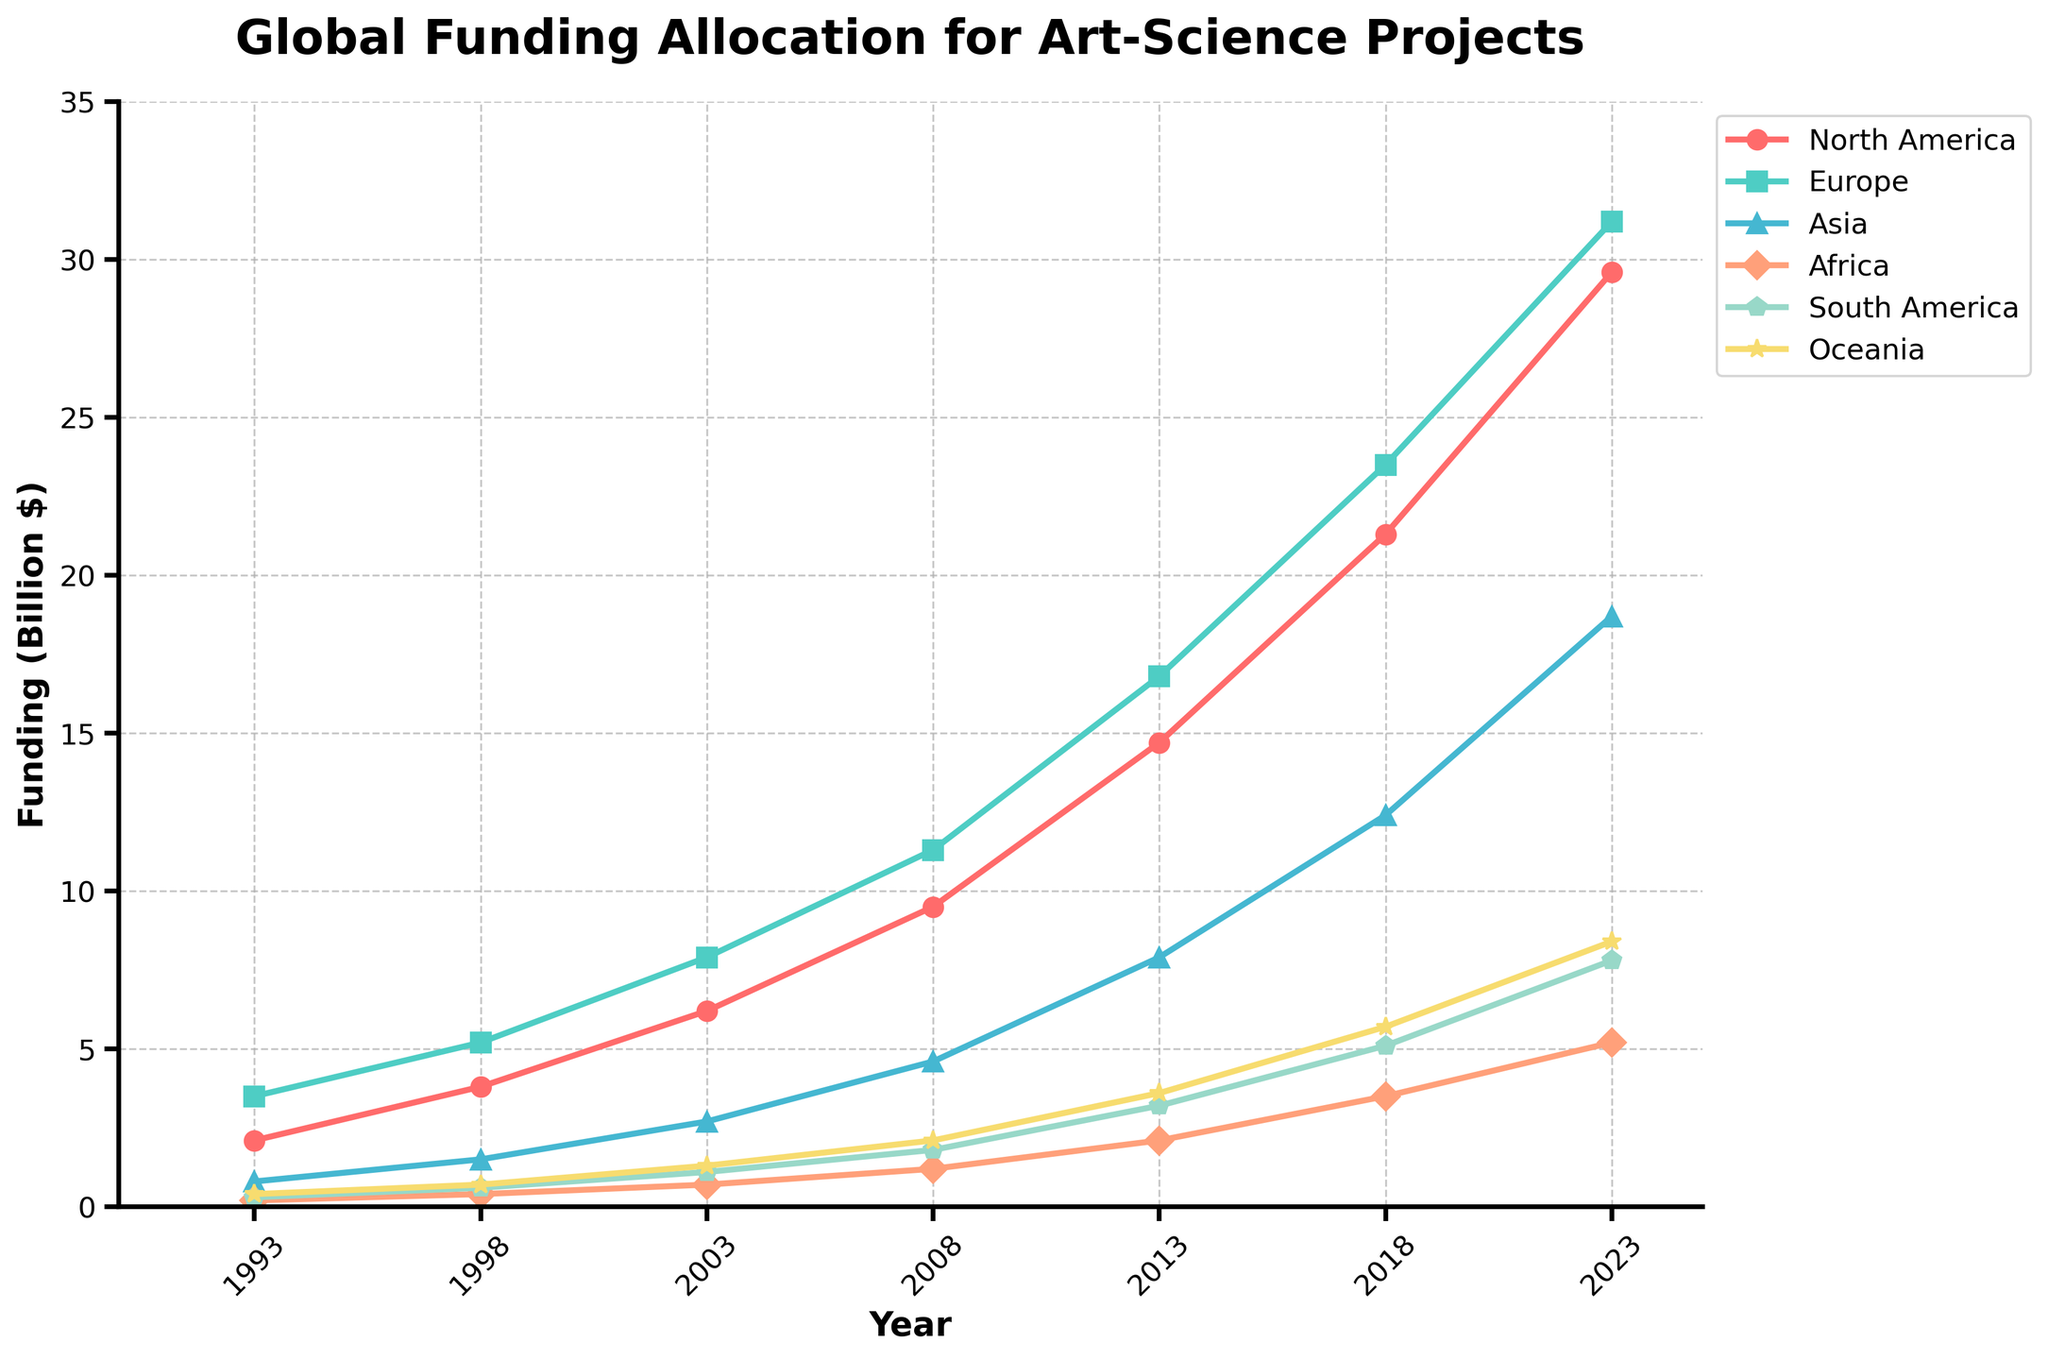Which continent had the highest funding allocation in 2023? To determine the highest funding in 2023, compare the funding values for each continent. North America has 29.6, Europe has 31.2, Asia has 18.7, Africa has 5.2, South America has 7.8, and Oceania has 8.4. Europe has the highest value.
Answer: Europe What is the overall trend of funding in North America over the 30 years? To determine the trend, observe the funding values for North America from 1993 to 2023: 2.1, 3.8, 6.2, 9.5, 14.7, 21.3, 29.6. There is a consistent increase in funding over the years.
Answer: Increasing Which continents had funding allocations below 5 billion dollars in 2008? Look at the funding values for each continent in 2008: North America 9.5, Europe 11.3, Asia 4.6, Africa 1.2, South America 1.8, and Oceania 2.1. The continents with funding below 5 billion dollars are Asia, Africa, South America, and Oceania.
Answer: Asia, Africa, South America, Oceania By how much did funding in Europe increase from 1993 to 2023? Subtract Europe's funding in 1993 from its funding in 2023. The funding in 1993 is 3.5 and in 2023 is 31.2. The increase is 31.2 - 3.5 = 27.7 billion dollars.
Answer: 27.7 billion dollars Which continent had the smallest funding increase over the 30 years? Calculate the difference between the 1993 and 2023 values for each continent: North America (29.6 - 2.1 = 27.5), Europe (31.2 - 3.5 = 27.7), Asia (18.7 - 0.8 = 17.9), Africa (5.2 - 0.2 = 5.0), South America (7.8 - 0.3 = 7.5), Oceania (8.4 - 0.4 = 8.0). Africa has the smallest increase.
Answer: Africa What is the difference between the funding allocated to Oceania and Africa in 2018? Find the funding for Oceania and Africa in 2018: Oceania 5.7, Africa 3.5. The difference is 5.7 - 3.5 = 2.2 billion dollars.
Answer: 2.2 billion dollars How did the funding for Asia change compared to North America from 1998 to 2008? Calculate the difference for Asia and North America between 1998 and 2008: Asia went from 1.5 to 4.6, an increase of 4.6 - 1.5 = 3.1 billion dollars. North America went from 3.8 to 9.5, an increase of 9.5 - 3.8 = 5.7 billion dollars. Funding for North America increased more than that for Asia.
Answer: North America increased more What is the average funding allocation for South America across all years provided? Sum the funding values for South America: 0.3, 0.6, 1.1, 1.8, 3.2, 5.1, 7.8. Total sum = 19.9. There are 7 years of data, so the average is 19.9 / 7 ≈ 2.84 billion dollars.
Answer: 2.84 billion dollars 